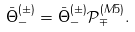<formula> <loc_0><loc_0><loc_500><loc_500>\bar { \Theta } ^ { ( \pm ) } _ { - } = \bar { \Theta } ^ { ( \pm ) } _ { - } \mathcal { P } ^ { ( M 5 ) } _ { \mp } .</formula> 